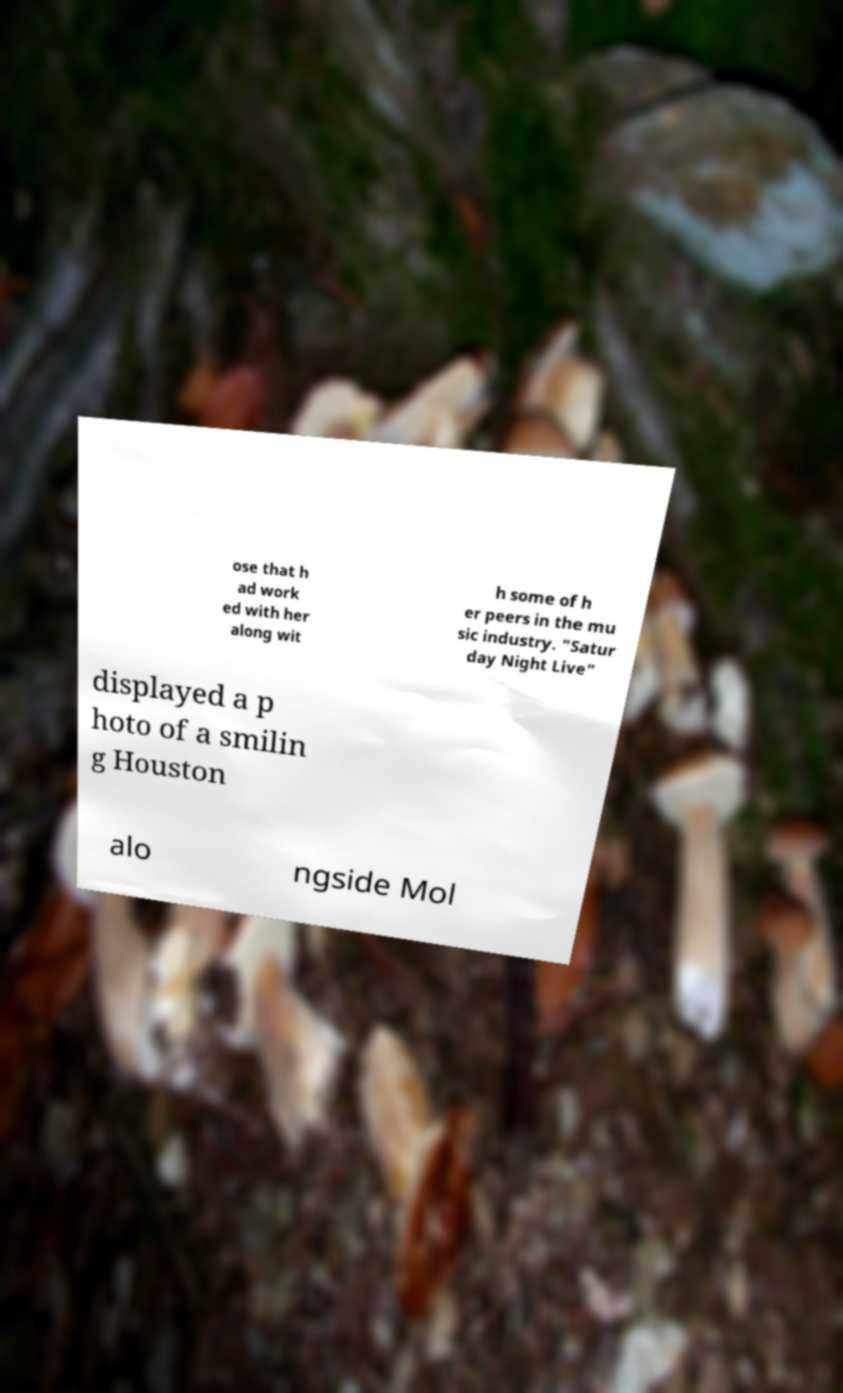Could you extract and type out the text from this image? ose that h ad work ed with her along wit h some of h er peers in the mu sic industry. "Satur day Night Live" displayed a p hoto of a smilin g Houston alo ngside Mol 